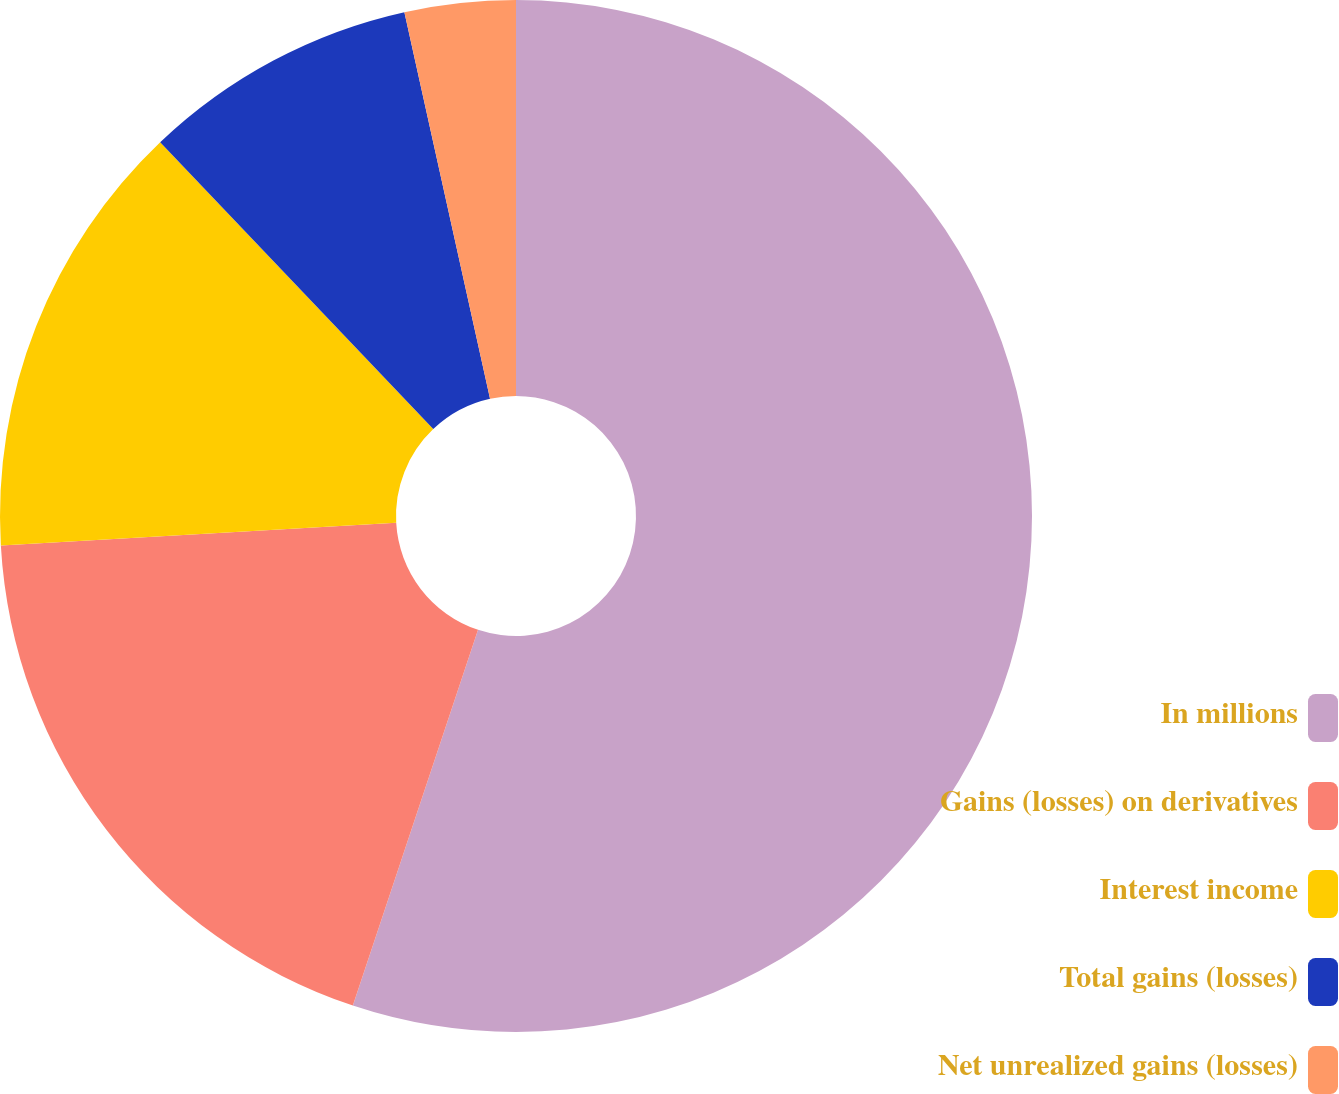<chart> <loc_0><loc_0><loc_500><loc_500><pie_chart><fcel>In millions<fcel>Gains (losses) on derivatives<fcel>Interest income<fcel>Total gains (losses)<fcel>Net unrealized gains (losses)<nl><fcel>55.12%<fcel>18.97%<fcel>13.8%<fcel>8.64%<fcel>3.47%<nl></chart> 